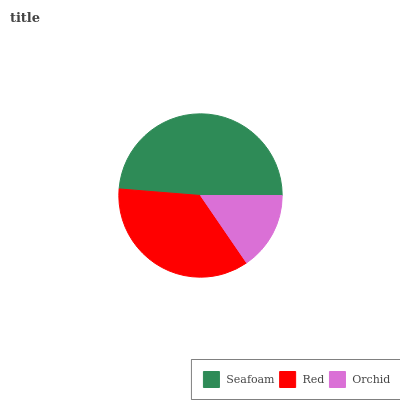Is Orchid the minimum?
Answer yes or no. Yes. Is Seafoam the maximum?
Answer yes or no. Yes. Is Red the minimum?
Answer yes or no. No. Is Red the maximum?
Answer yes or no. No. Is Seafoam greater than Red?
Answer yes or no. Yes. Is Red less than Seafoam?
Answer yes or no. Yes. Is Red greater than Seafoam?
Answer yes or no. No. Is Seafoam less than Red?
Answer yes or no. No. Is Red the high median?
Answer yes or no. Yes. Is Red the low median?
Answer yes or no. Yes. Is Orchid the high median?
Answer yes or no. No. Is Orchid the low median?
Answer yes or no. No. 